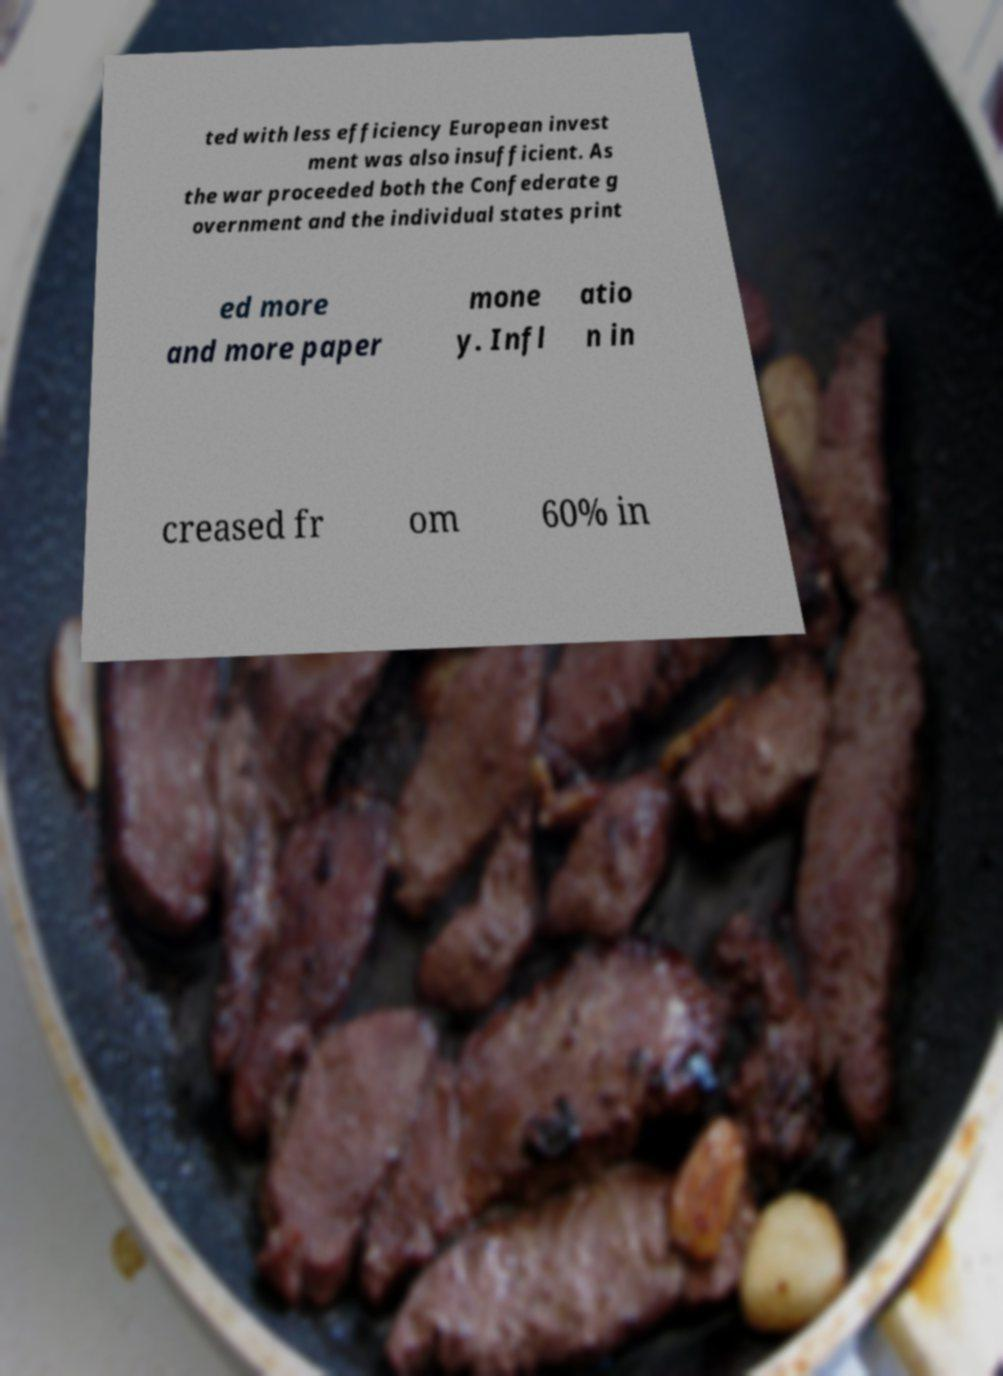Could you extract and type out the text from this image? ted with less efficiency European invest ment was also insufficient. As the war proceeded both the Confederate g overnment and the individual states print ed more and more paper mone y. Infl atio n in creased fr om 60% in 